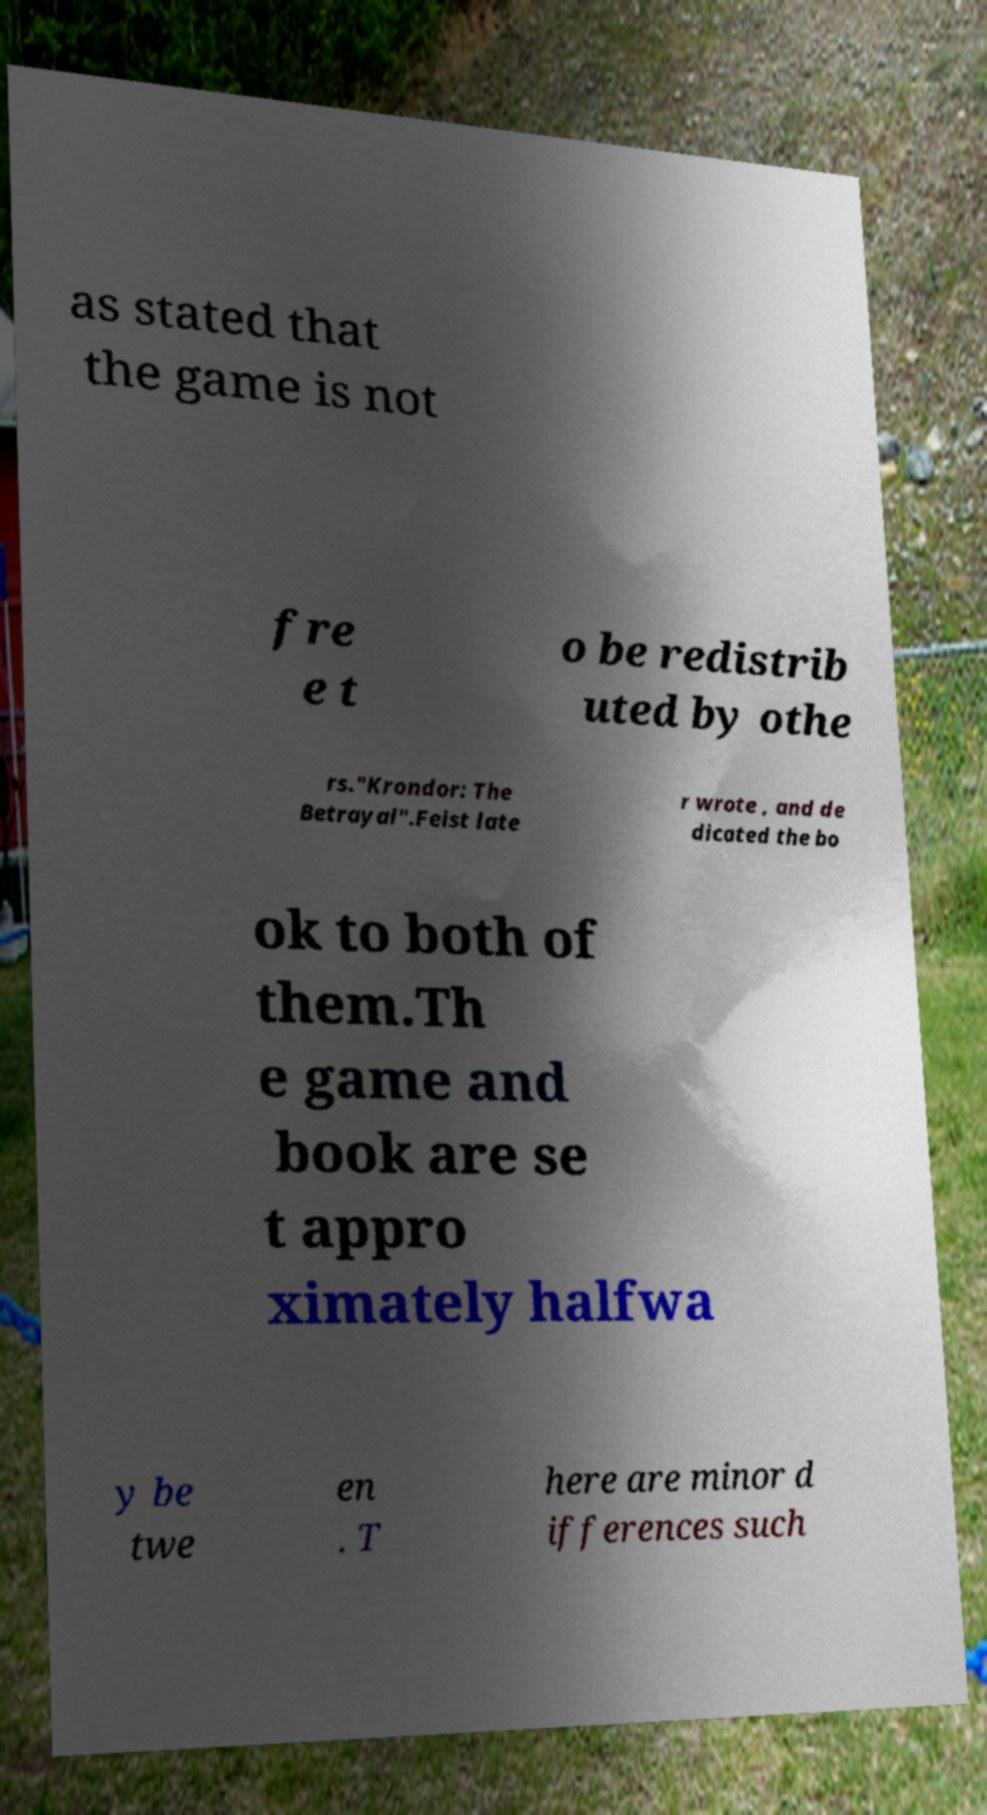Can you read and provide the text displayed in the image?This photo seems to have some interesting text. Can you extract and type it out for me? as stated that the game is not fre e t o be redistrib uted by othe rs."Krondor: The Betrayal".Feist late r wrote , and de dicated the bo ok to both of them.Th e game and book are se t appro ximately halfwa y be twe en . T here are minor d ifferences such 